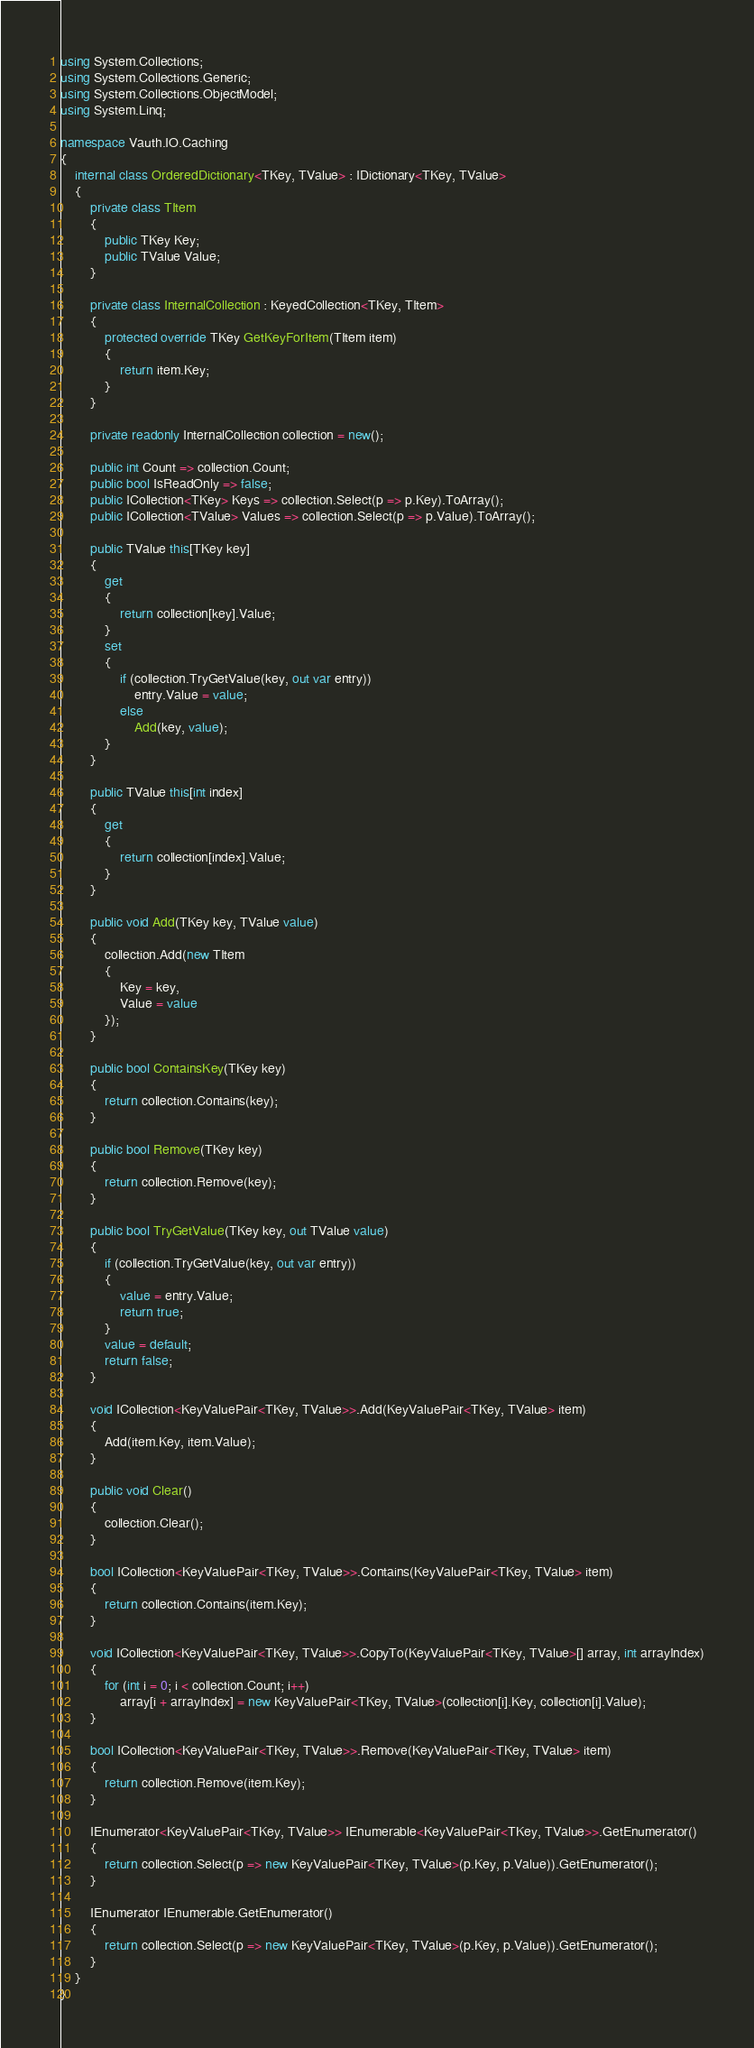<code> <loc_0><loc_0><loc_500><loc_500><_C#_>using System.Collections;
using System.Collections.Generic;
using System.Collections.ObjectModel;
using System.Linq;

namespace Vauth.IO.Caching
{
    internal class OrderedDictionary<TKey, TValue> : IDictionary<TKey, TValue>
    {
        private class TItem
        {
            public TKey Key;
            public TValue Value;
        }

        private class InternalCollection : KeyedCollection<TKey, TItem>
        {
            protected override TKey GetKeyForItem(TItem item)
            {
                return item.Key;
            }
        }

        private readonly InternalCollection collection = new();

        public int Count => collection.Count;
        public bool IsReadOnly => false;
        public ICollection<TKey> Keys => collection.Select(p => p.Key).ToArray();
        public ICollection<TValue> Values => collection.Select(p => p.Value).ToArray();

        public TValue this[TKey key]
        {
            get
            {
                return collection[key].Value;
            }
            set
            {
                if (collection.TryGetValue(key, out var entry))
                    entry.Value = value;
                else
                    Add(key, value);
            }
        }

        public TValue this[int index]
        {
            get
            {
                return collection[index].Value;
            }
        }

        public void Add(TKey key, TValue value)
        {
            collection.Add(new TItem
            {
                Key = key,
                Value = value
            });
        }

        public bool ContainsKey(TKey key)
        {
            return collection.Contains(key);
        }

        public bool Remove(TKey key)
        {
            return collection.Remove(key);
        }

        public bool TryGetValue(TKey key, out TValue value)
        {
            if (collection.TryGetValue(key, out var entry))
            {
                value = entry.Value;
                return true;
            }
            value = default;
            return false;
        }

        void ICollection<KeyValuePair<TKey, TValue>>.Add(KeyValuePair<TKey, TValue> item)
        {
            Add(item.Key, item.Value);
        }

        public void Clear()
        {
            collection.Clear();
        }

        bool ICollection<KeyValuePair<TKey, TValue>>.Contains(KeyValuePair<TKey, TValue> item)
        {
            return collection.Contains(item.Key);
        }

        void ICollection<KeyValuePair<TKey, TValue>>.CopyTo(KeyValuePair<TKey, TValue>[] array, int arrayIndex)
        {
            for (int i = 0; i < collection.Count; i++)
                array[i + arrayIndex] = new KeyValuePair<TKey, TValue>(collection[i].Key, collection[i].Value);
        }

        bool ICollection<KeyValuePair<TKey, TValue>>.Remove(KeyValuePair<TKey, TValue> item)
        {
            return collection.Remove(item.Key);
        }

        IEnumerator<KeyValuePair<TKey, TValue>> IEnumerable<KeyValuePair<TKey, TValue>>.GetEnumerator()
        {
            return collection.Select(p => new KeyValuePair<TKey, TValue>(p.Key, p.Value)).GetEnumerator();
        }

        IEnumerator IEnumerable.GetEnumerator()
        {
            return collection.Select(p => new KeyValuePair<TKey, TValue>(p.Key, p.Value)).GetEnumerator();
        }
    }
}
</code> 